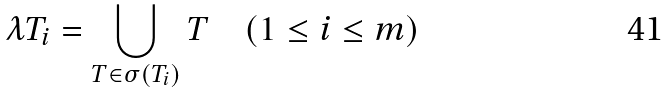<formula> <loc_0><loc_0><loc_500><loc_500>\lambda T _ { i } = \bigcup _ { T \in \sigma ( T _ { i } ) } T \quad ( 1 \leq i \leq m )</formula> 